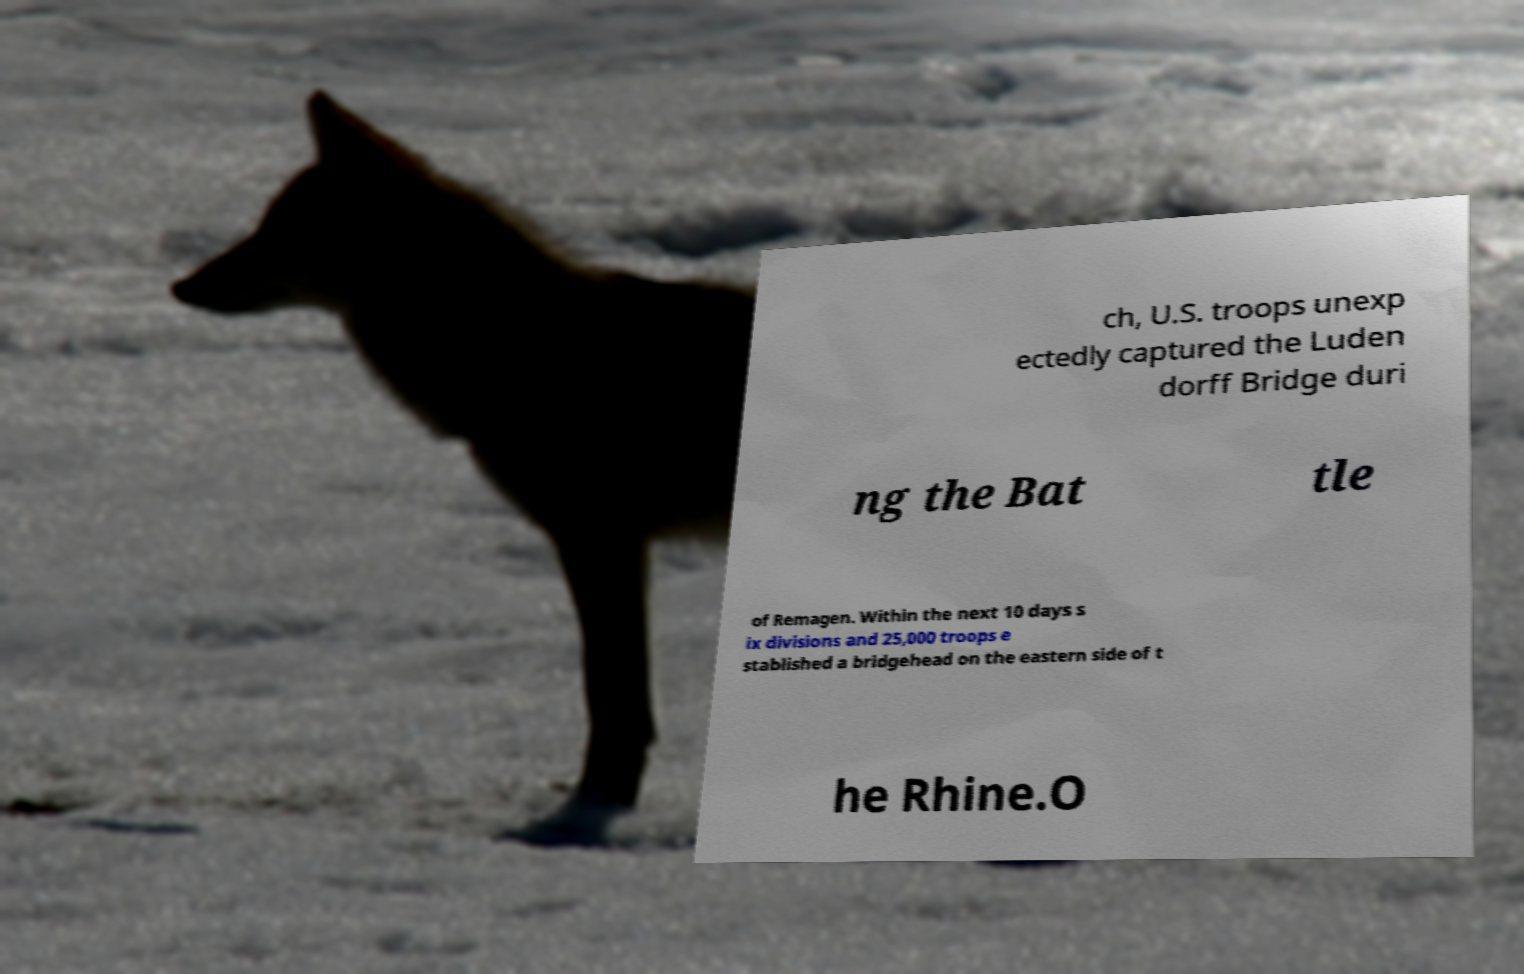I need the written content from this picture converted into text. Can you do that? ch, U.S. troops unexp ectedly captured the Luden dorff Bridge duri ng the Bat tle of Remagen. Within the next 10 days s ix divisions and 25,000 troops e stablished a bridgehead on the eastern side of t he Rhine.O 